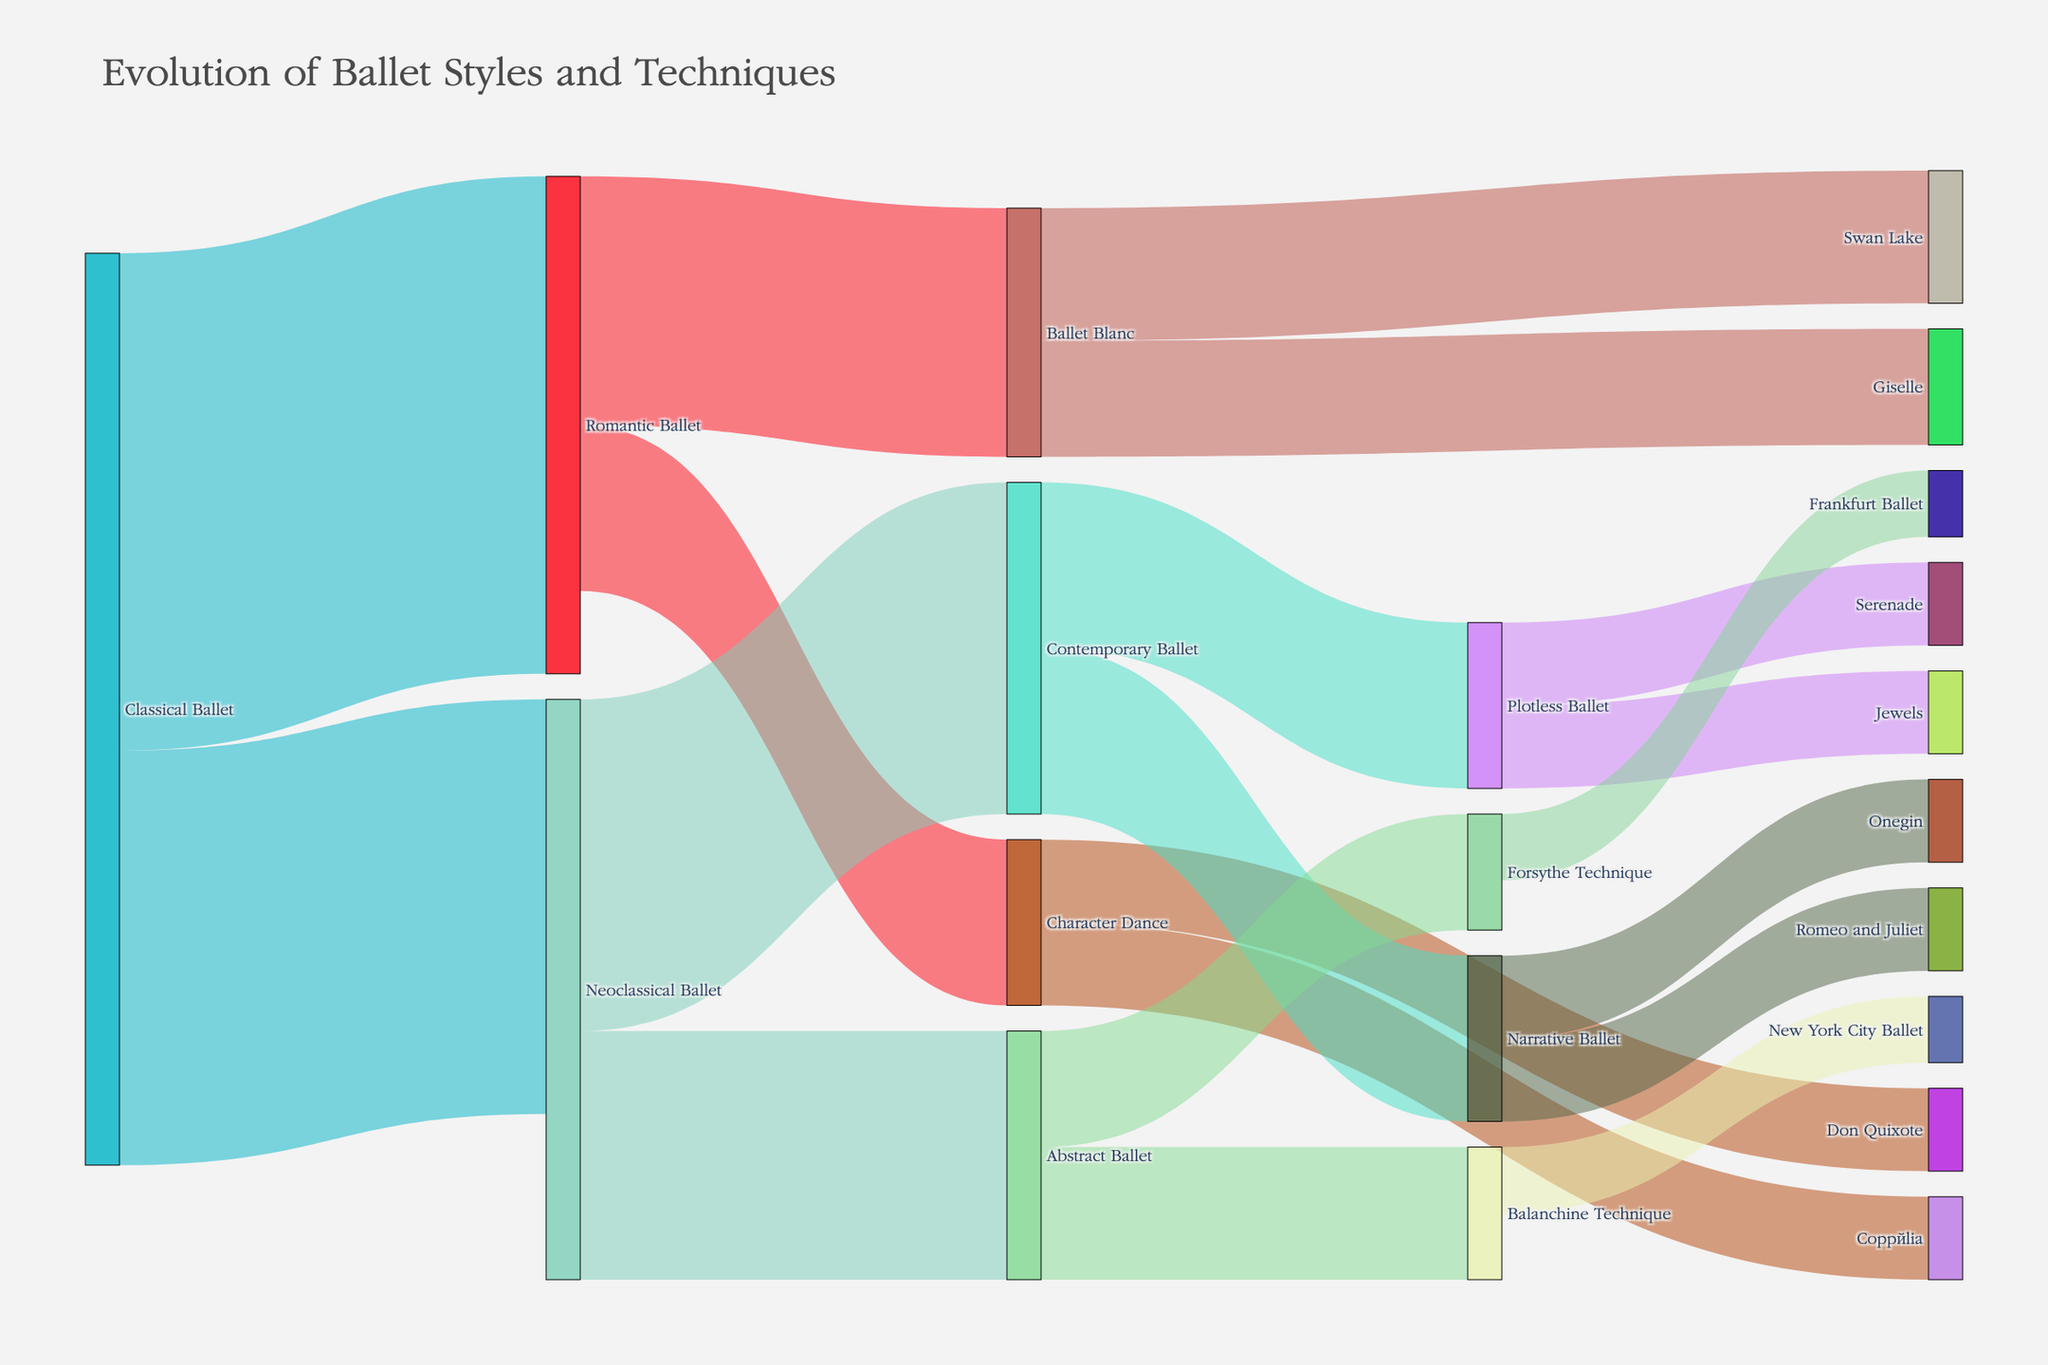What is the title of the Sankey Diagram? The title is located at the top of the figure and provides a description of the chart. The title reads, "Evolution of Ballet Styles and Techniques".
Answer: Evolution of Ballet Styles and Techniques How many different ballet styles are shown as nodes in the Sankey Diagram? Count all the unique labels in the nodes representing different ballet styles and techniques.
Answer: 19 Which ballet style transitions to the greatest number of other styles? Identify the node with the most outgoing links by counting the connections originating from each node. "Neoclassical Ballet" has the most with two transitions (to Contemporary Ballet and Abstract Ballet).
Answer: Neoclassical Ballet What is the total value of transitions from Romantic Ballet? Sum the values of all links originating from "Romantic Ballet". The values are 15 (Ballet Blanc) + 10 (Character Dance) = 25.
Answer: 25 Which ballet technique associated with the highest number of successors directly connects to "Contemporary Ballet"? Analyze the successors (styles connected directly) of "Contemporary Ballet" and count them. "Contemporary Ballet" transitions to two distinct ballet types: Narrative Ballet and Plotless Ballet, both with values of 10.
Answer: Both Narrative Ballet and Plotless Ballet (2 successors each) What is the combined value of all transitions to "Abstract Ballet"? Sum the values of all links where "Abstract Ballet" is the target node. The only transition to "Abstract Ballet" is from "Neoclassical Ballet" with a value of 15.
Answer: 15 Does "Character Dance" have more transitions leading to performances ("Swan Lake", "Giselle", "Don Quixote", "Coppélia") compared to transitions leading from it? Compare the number of links leading from "Character Dance" to the number of links leading to performances. "Character Dance" has 2 transitions leading to "Don Quixote" and "Coppélia" (both 5 each). There are no transitions leading to "Character Dance" directly involving performances.
Answer: No Which ballet technique connects to a company with the highest transition value? Identify the link with the highest value that connects a ballet technique to a company. Both "Balanchine Technique" to "New York City Ballet" and "Forsythe Technique" to "Frankfurt Ballet" have values of 4, which are the highest values connecting techniques to companies.
Answer: Both New York City Ballet and Frankfurt Ballet What is the total combined value of transitions from "Classical Ballet"? Sum the values of all links originating from "Classical Ballet". The values are 30 (Romantic Ballet) + 25 (Neoclassical Ballet) = 55.
Answer: 55 What percentage of transitions from "Contemporary Ballet" goes to "Plotless Ballet"? Calculate the percentage by dividing the value of the transition to "Plotless Ballet" by the total transitions originating from "Contemporary Ballet". The total transitions from "Contemporary Ballet" are 10 (Narrative Ballet) + 10 (Plotless Ballet) = 20. The percentage is (10 / 20) * 100.
Answer: 50% 